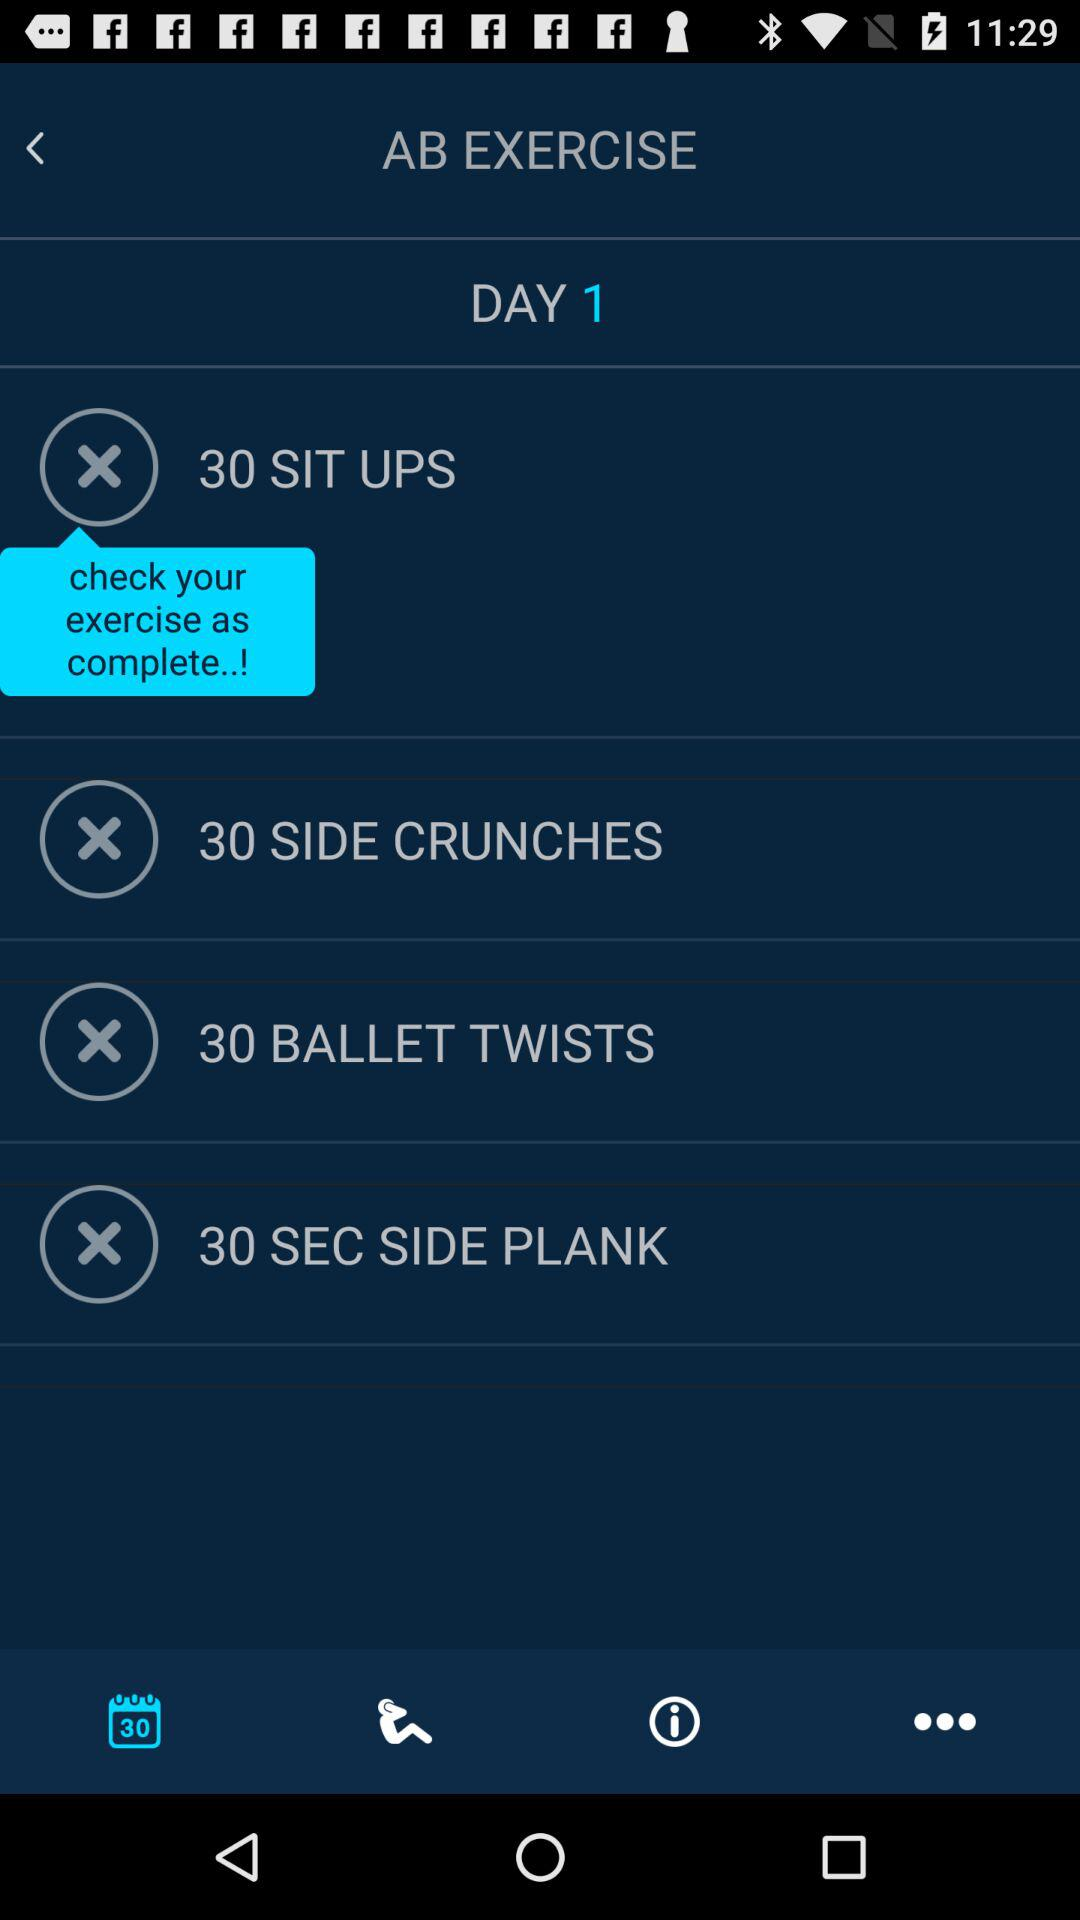What are the Ab exercises for day 1? The Ab exercises for day 1 are "30 SIT UPS", "30 SIDE CRUNCHES", "30 BALLET TWISTS" and "30 SEC SIDE PLANK". 